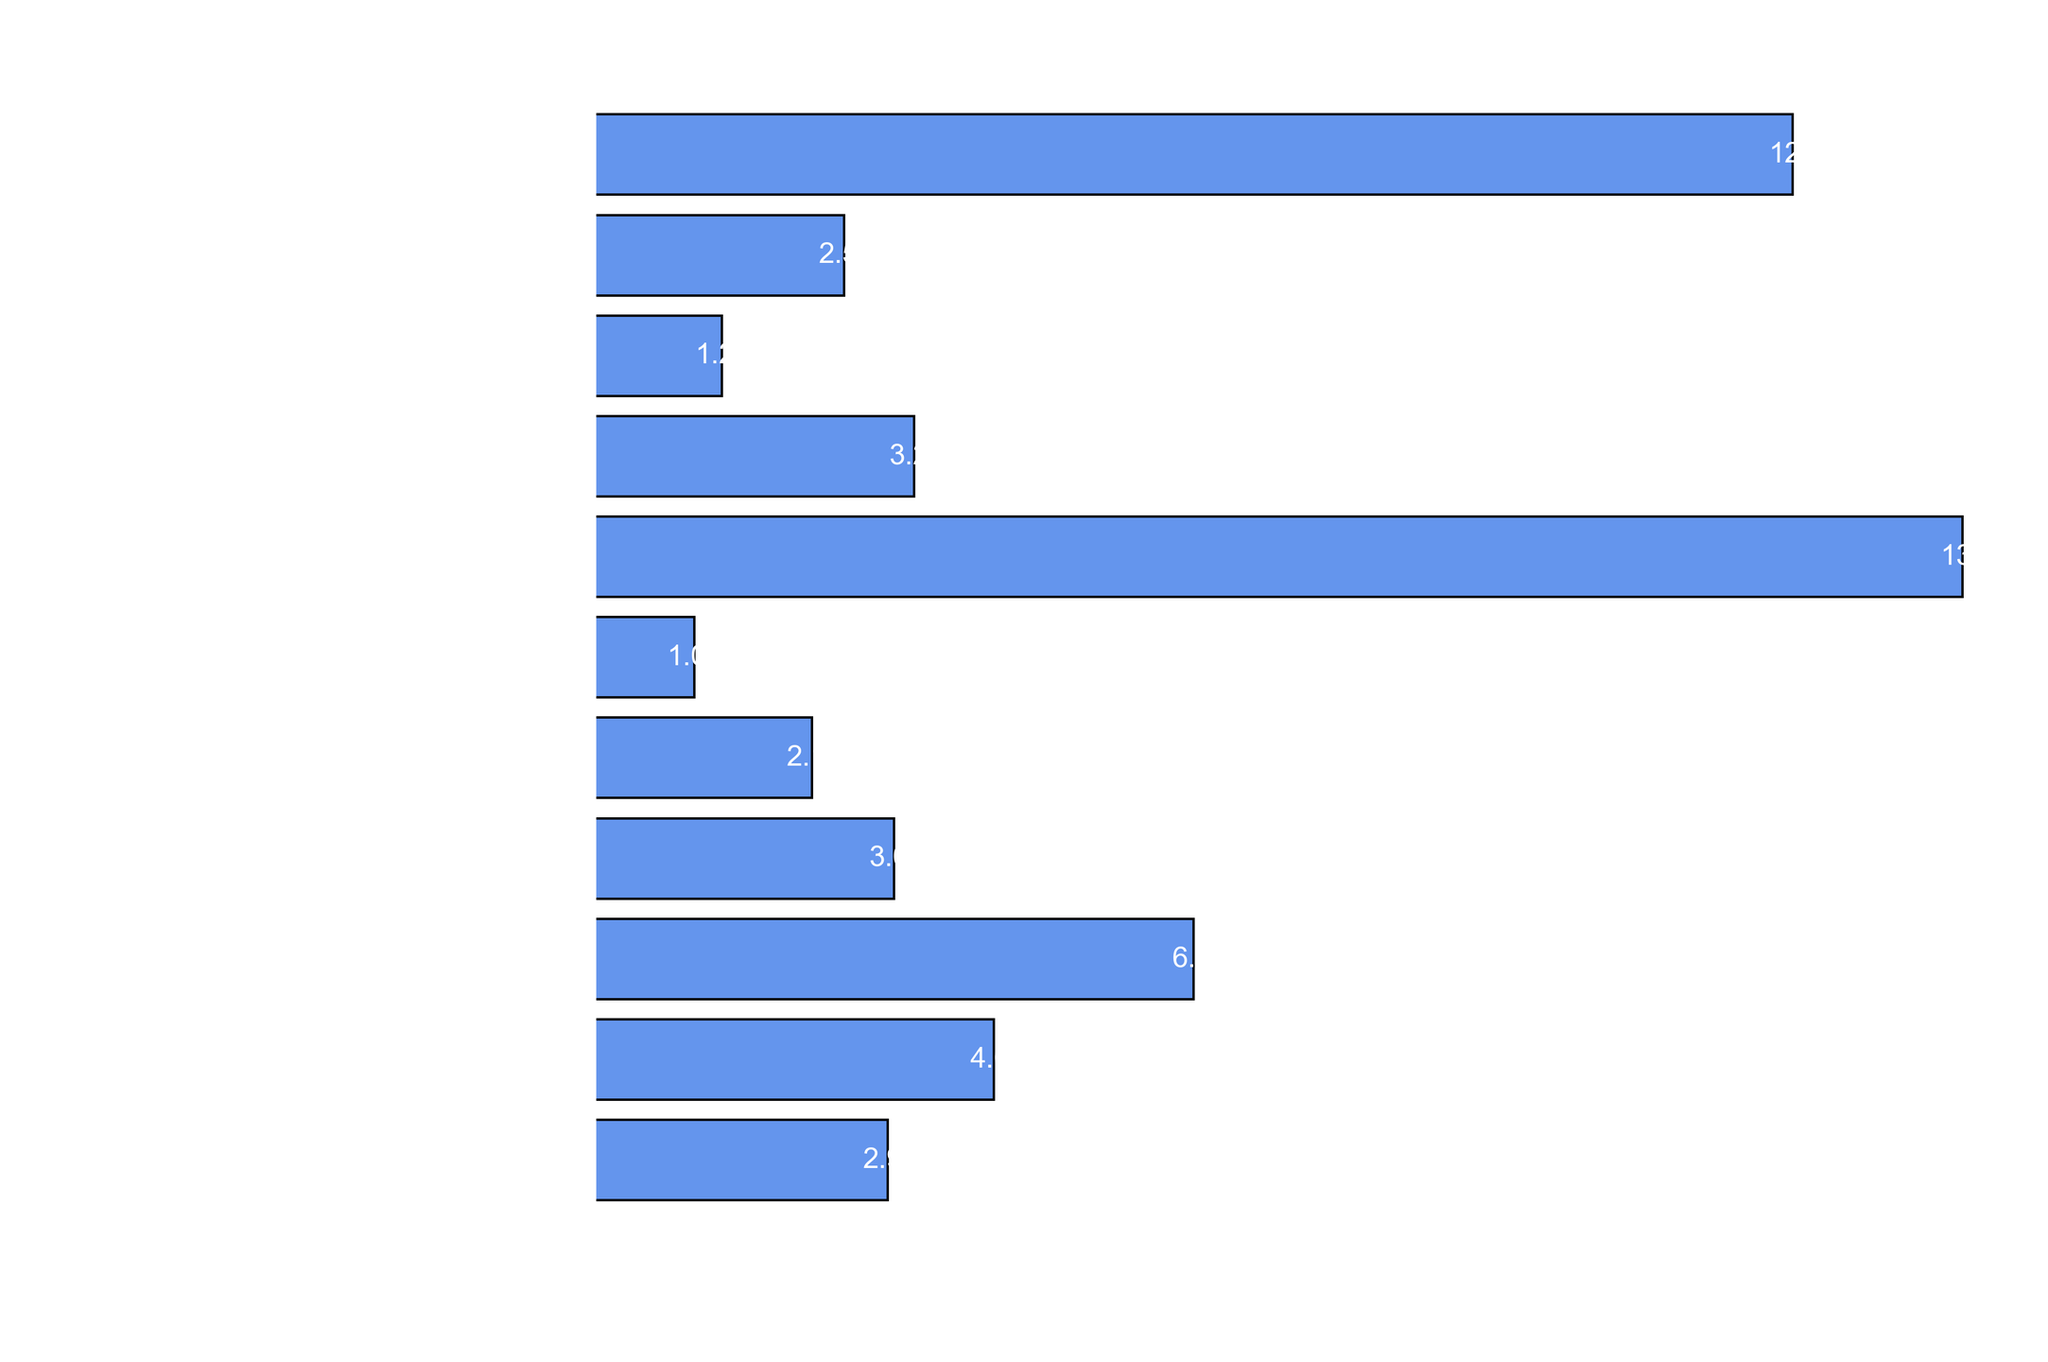Which game has the highest sales figures? The figure shows that 'Cyberpunk 2077' has the longest bar, indicating the highest sales figures among the depicted games.
Answer: Cyberpunk 2077 Which Mass Effect game has the lowest sales figures? Among the Mass Effect games, 'Mass Effect' has the smallest sales figure, shown by the shortest bar.
Answer: Mass Effect How do the sales figures of Mass Effect 3 compare to Fallout: New Vegas? 'Mass Effect 3' shows a shorter bar than 'Fallout: New Vegas', indicating that 'Fallout: New Vegas' has higher sales figures.
Answer: Fallout: New Vegas has higher sales than Mass Effect 3 What is the combined sales figure of The Outer Worlds, Deus Ex: Human Revolution, and Mass Effect Andromeda? The sales figures are 2.5, 2.18, and 3 million respectively. Adding these together, 2.5 + 2.18 + 3 = 7.68 million.
Answer: 7.68 million Which has higher sales, Mass Effect 2 or Star Wars: Knights of the Old Republic? 'Mass Effect 2' has a longer bar showing 4 million in sales, whereas 'Star Wars: Knights of the Old Republic' shows a shorter bar with 3.2 million sales.
Answer: Mass Effect 2 What is the difference in sales between Cyberpunk 2077 and Deus Ex: Mankind Divided? Cyberpunk 2077 has sales of 13.7 million, and Deus Ex: Mankind Divided has sales of 1 million. The difference is 13.7 - 1 = 12.7 million.
Answer: 12.7 million Which game has the second highest sales figures? The figure shows 'Fallout: New Vegas' has the second longest bar after 'Cyberpunk 2077', indicating it has the second highest sales.
Answer: Fallout: New Vegas How many games have sales figures above 5 million? Counting the bars with lengths indicating sales figures above 5 million, 'Mass Effect 3', 'Fallout: New Vegas', and 'Cyberpunk 2077' are above 5 million.
Answer: 3 games Compare the total sales of all Mass Effect games combined to Cyberpunk 2077. Which is higher? Adding the sales of all Mass Effect games: 2.94(Mass Effect) + 4(Mass Effect 2) + 6(Mass Effect 3) + 3(Mass Effect Andromeda) = 15.94 million. Comparing this to Cyberpunk 2077 which is 13.7 million, Mass Effect games combined have higher sales.
Answer: Mass Effect games combined What is the average sales figure of the Deus Ex games? The sales figures for Deus Ex games are 2.18 million (Human Revolution) and 1 million (Mankind Divided). The average is (2.18 + 1) / 2 = 1.59 million.
Answer: 1.59 million 